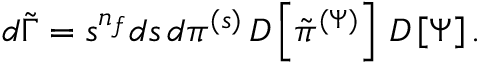Convert formula to latex. <formula><loc_0><loc_0><loc_500><loc_500>\begin{array} { r } { d \tilde { \Gamma } = s ^ { n _ { f } } d s \, d \pi ^ { ( s ) } \, D \left [ \tilde { \pi } ^ { ( \Psi ) } \right ] \, D \left [ \Psi \right ] . } \end{array}</formula> 